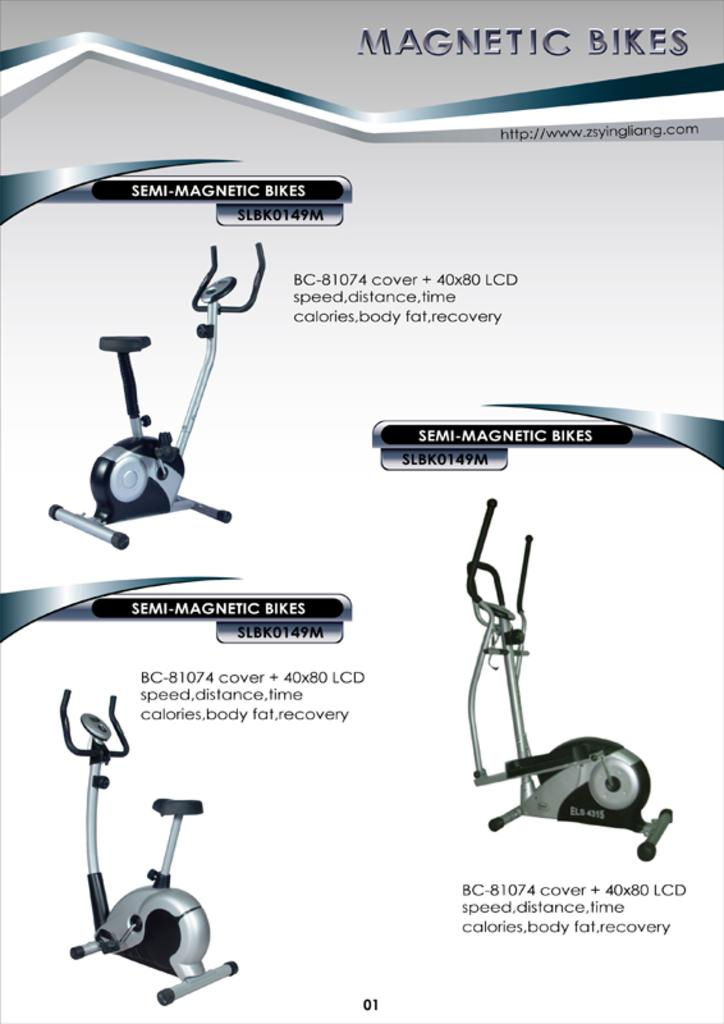What is featured on the poster in the image? There is a poster in the image that contains images of three magnetic bikes. What else can be found on the poster besides the images of the bikes? There is text on the poster. What type of bubbles can be seen floating around the magnetic bikes in the image? There are no bubbles present in the image; it features a poster with images of three magnetic bikes and text. What kind of boats are visible in the image? There are no boats present in the image; it features a poster with images of three magnetic bikes and text. 